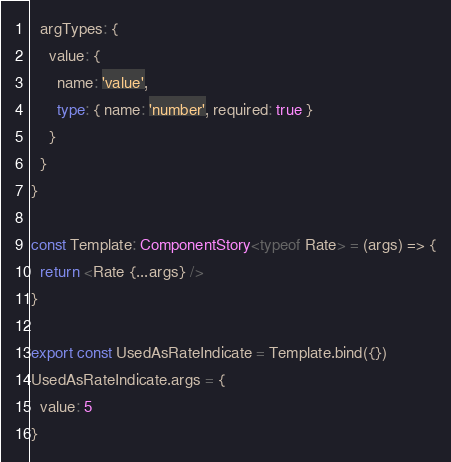Convert code to text. <code><loc_0><loc_0><loc_500><loc_500><_TypeScript_>  argTypes: {
    value: {
      name: 'value',
      type: { name: 'number', required: true }
    }
  }
}

const Template: ComponentStory<typeof Rate> = (args) => {
  return <Rate {...args} />
}

export const UsedAsRateIndicate = Template.bind({})
UsedAsRateIndicate.args = {
  value: 5
}
</code> 